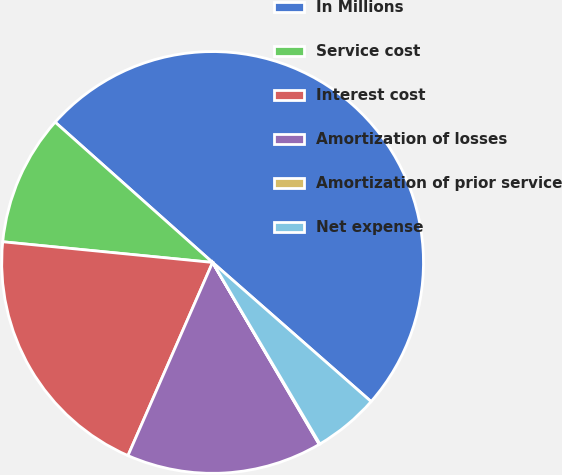<chart> <loc_0><loc_0><loc_500><loc_500><pie_chart><fcel>In Millions<fcel>Service cost<fcel>Interest cost<fcel>Amortization of losses<fcel>Amortization of prior service<fcel>Net expense<nl><fcel>49.88%<fcel>10.02%<fcel>19.99%<fcel>15.01%<fcel>0.06%<fcel>5.04%<nl></chart> 